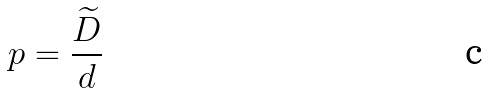<formula> <loc_0><loc_0><loc_500><loc_500>p = \frac { \widetilde { D } } { d }</formula> 